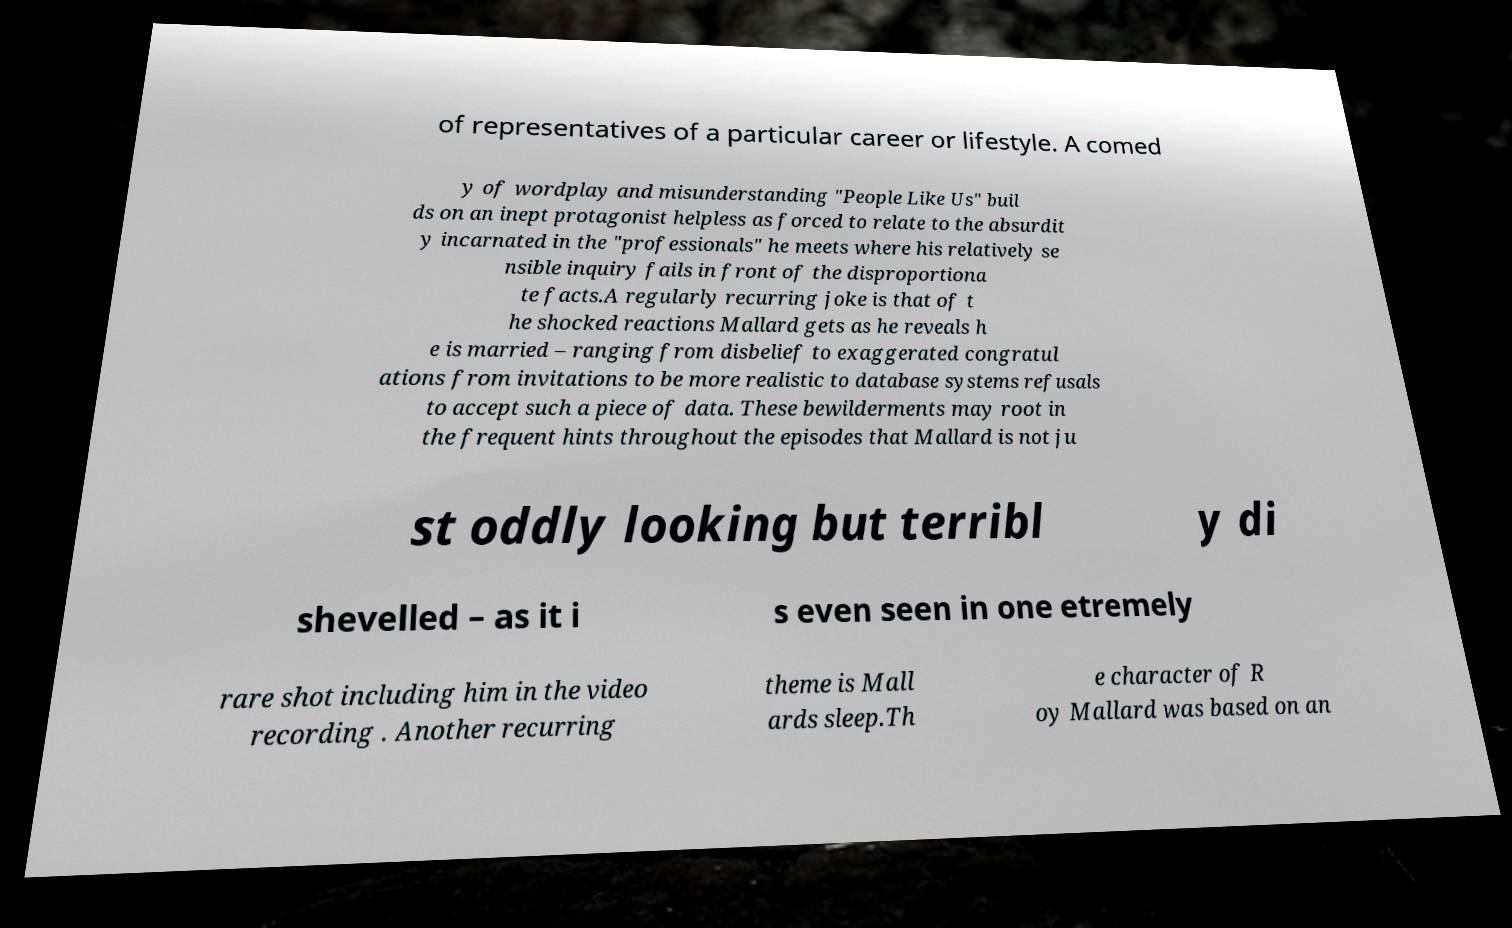Can you read and provide the text displayed in the image?This photo seems to have some interesting text. Can you extract and type it out for me? of representatives of a particular career or lifestyle. A comed y of wordplay and misunderstanding "People Like Us" buil ds on an inept protagonist helpless as forced to relate to the absurdit y incarnated in the "professionals" he meets where his relatively se nsible inquiry fails in front of the disproportiona te facts.A regularly recurring joke is that of t he shocked reactions Mallard gets as he reveals h e is married – ranging from disbelief to exaggerated congratul ations from invitations to be more realistic to database systems refusals to accept such a piece of data. These bewilderments may root in the frequent hints throughout the episodes that Mallard is not ju st oddly looking but terribl y di shevelled – as it i s even seen in one etremely rare shot including him in the video recording . Another recurring theme is Mall ards sleep.Th e character of R oy Mallard was based on an 